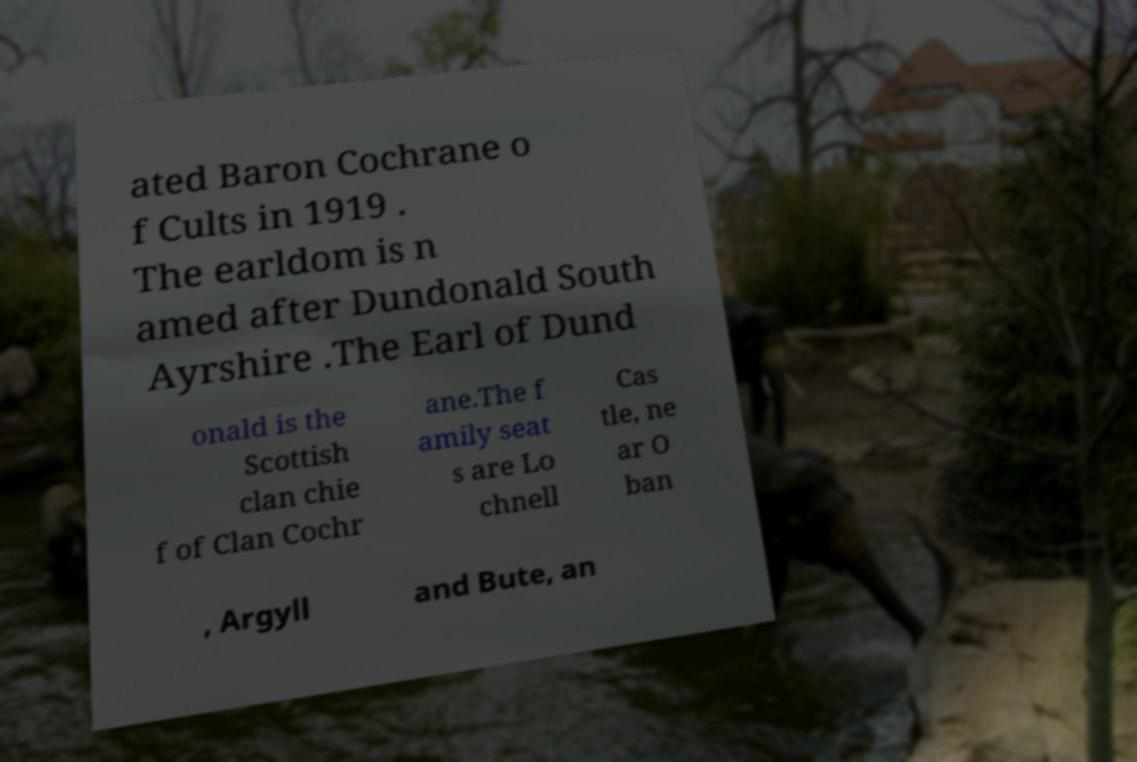Can you accurately transcribe the text from the provided image for me? ated Baron Cochrane o f Cults in 1919 . The earldom is n amed after Dundonald South Ayrshire .The Earl of Dund onald is the Scottish clan chie f of Clan Cochr ane.The f amily seat s are Lo chnell Cas tle, ne ar O ban , Argyll and Bute, an 